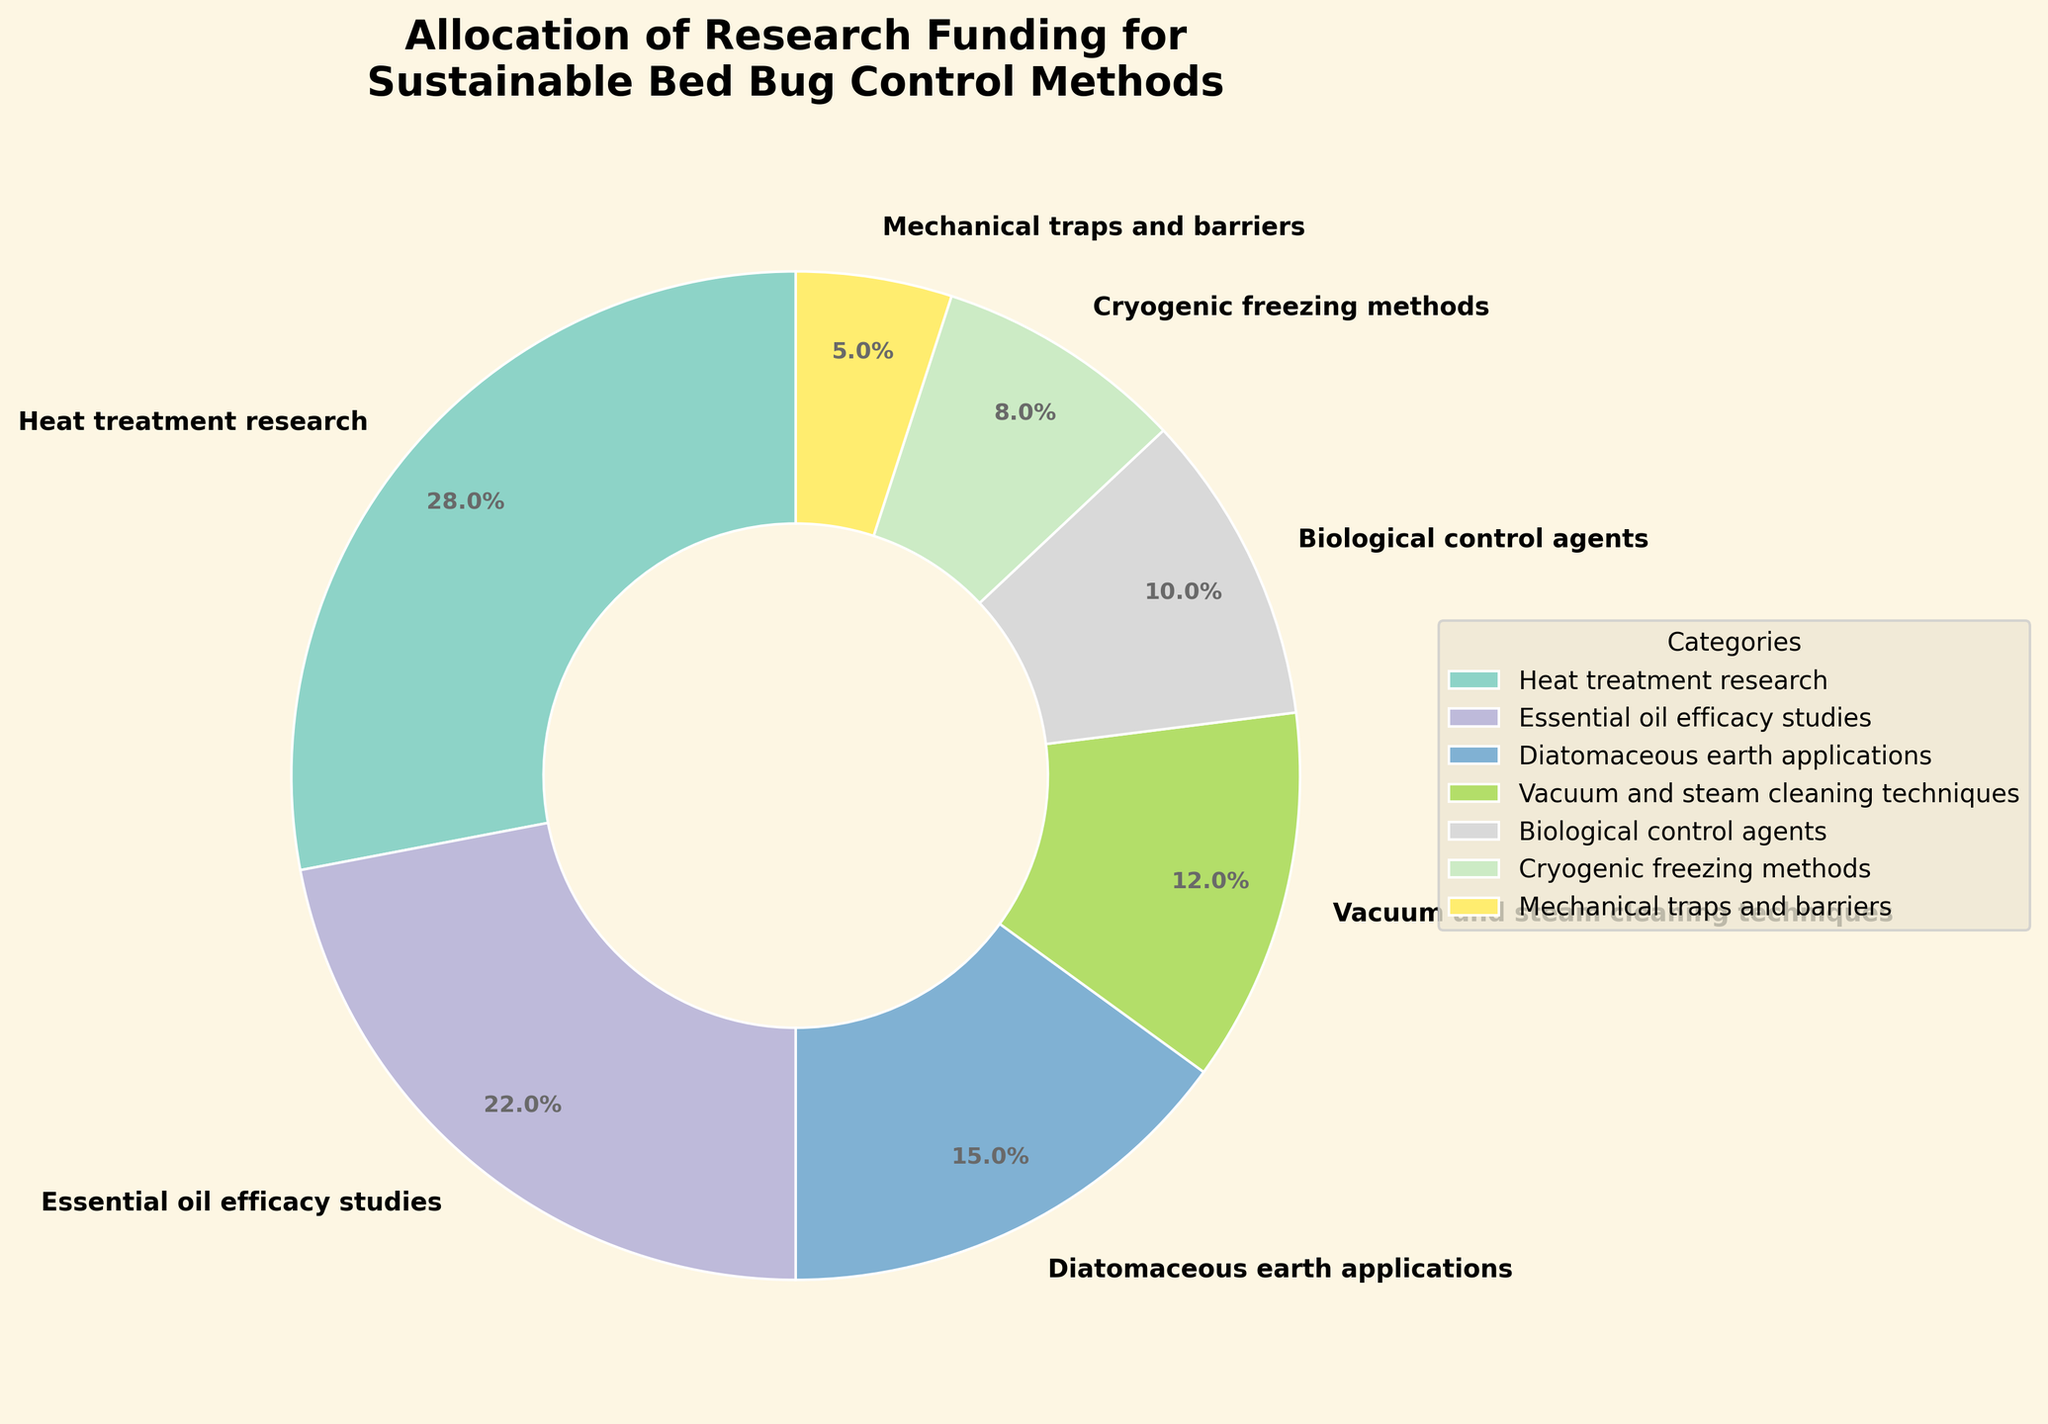Which category has the highest funding percentage? The category with the largest slice in the pie chart represents the highest funding percentage. By observing the slices, "Heat treatment research" appears to occupy the largest segment at 28%.
Answer: Heat treatment research Which two categories combined have a funding percentage close to 50%? Combining categories can be done by summing their funding percentages. "Heat treatment research" is 28%, and "Essential oil efficacy studies" is 22%. Together, they sum to 50%, which is close to the targeted total.
Answer: Heat treatment research and Essential oil efficacy studies How much more funding percentage does "Heat treatment research" receive compared to "Mechanical traps and barriers"? Subtract the funding percentage for "Mechanical traps and barriers" from that of "Heat treatment research". This is 28% - 5% = 23%. "Heat treatment research" receives 23% more funding.
Answer: 23% Order the categories by funding percentage from highest to lowest. To order the categories, list them by descending funding percentages: Heat treatment research (28%), Essential oil efficacy studies (22%), Diatomaceous earth applications (15%), Vacuum and steam cleaning techniques (12%), Biological control agents (10%), Cryogenic freezing methods (8%), Mechanical traps and barriers (5%).
Answer: Heat treatment research, Essential oil efficacy studies, Diatomaceous earth applications, Vacuum and steam cleaning techniques, Biological control agents, Cryogenic freezing methods, Mechanical traps and barriers What is the total funding percentage for non-chemical methods? Sum the percentages for each non-chemical method category: Heat treatment research (28%), Diatomaceous earth applications (15%), Vacuum and steam cleaning techniques (12%), Cryogenic freezing methods (8%), Mechanical traps and barriers (5%). Total is 28% + 15% + 12% + 8% + 5% = 68%.
Answer: 68% Which category has the smallest funding percentage, and what is it? The category with the smallest slice in the pie chart represents the lowest funding percentage. "Mechanical traps and barriers" appears to have the smallest slice at 5%.
Answer: Mechanical traps and barriers, 5% Is there a category that has double the funding percentage of "Mechanical traps and barriers"? If yes, which one? Double the funding percentage of "Mechanical traps and barriers" is 5% * 2 = 10%. The "Biological control agents" category has exactly 10% funding, which matches our requirement.
Answer: Biological control agents Compare the funding percentages for "Diatomaceous earth applications" and "Vacuum and steam cleaning techniques". Which one has a higher percentage and by how much? Subtract the percentage of "Vacuum and steam cleaning techniques" from "Diatomaceous earth applications": 15% - 12% = 3%. "Diatomaceous earth applications" has 3% more.
Answer: Diatomaceous earth applications by 3% Which category's slice appears most similar in size to "Biological control agents"? Observing the slices, "Cryogenic freezing methods" looks most similar in size to “Biological control agents”, with percentages being 10% and 8% respectively.
Answer: Cryogenic freezing methods 